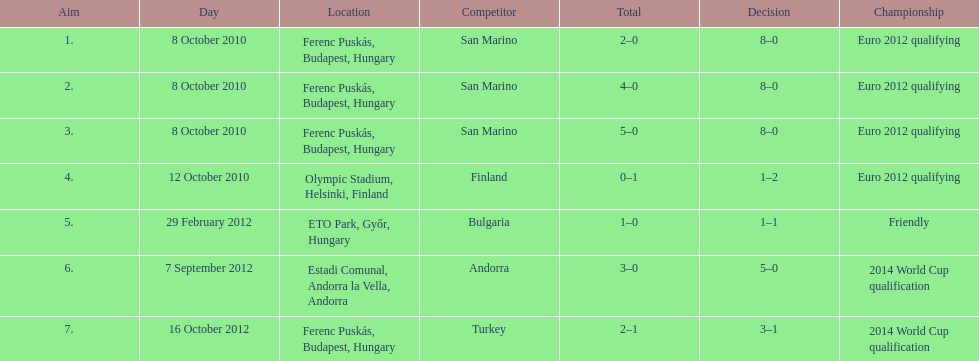Szalai scored all but one of his international goals in either euro 2012 qualifying or what other level of play? 2014 World Cup qualification. 